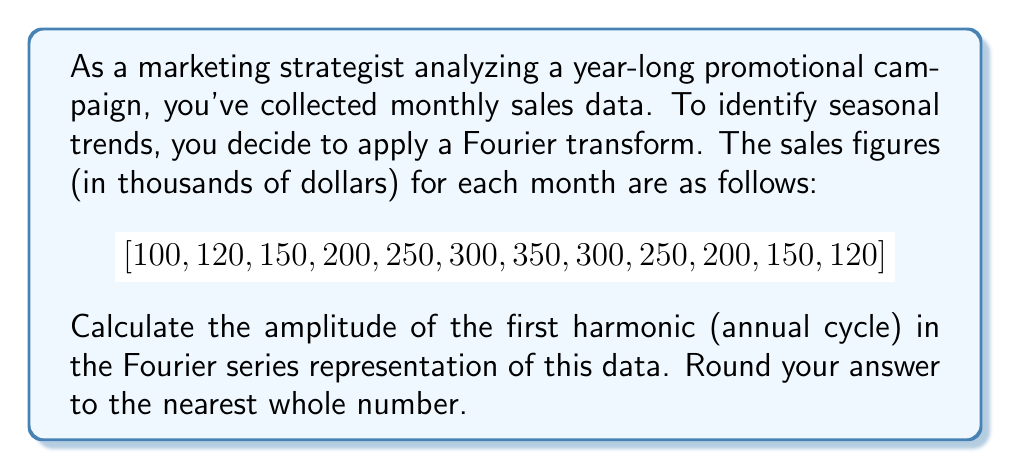Show me your answer to this math problem. To find the amplitude of the first harmonic using the Fourier transform, we'll follow these steps:

1) The first harmonic represents the annual cycle, so we need to calculate the coefficient for $k=1$ in the Fourier series.

2) For a discrete set of N=12 data points, the complex Fourier coefficient $c_k$ is given by:

   $$c_k = \frac{1}{N} \sum_{n=0}^{N-1} x_n e^{-2\pi i k n / N}$$

3) For the first harmonic (k=1), we need to calculate:

   $$c_1 = \frac{1}{12} \sum_{n=0}^{11} x_n e^{-2\pi i n / 12}$$

4) This can be separated into real and imaginary parts:

   $$c_1 = \frac{1}{12} \sum_{n=0}^{11} x_n (\cos(-2\pi n / 12) + i \sin(-2\pi n / 12))$$

5) Calculating this sum:

   Real part: $\frac{1}{12}(100 + 120\cos(-\frac{\pi}{6}) + 150\cos(-\frac{\pi}{3}) + ... + 120\cos(-\frac{11\pi}{6})) \approx -41.67$

   Imaginary part: $\frac{1}{12}(120\sin(-\frac{\pi}{6}) + 150\sin(-\frac{\pi}{3}) + ... + 120\sin(-\frac{11\pi}{6})) \approx -72.17$

6) The amplitude $A_1$ is given by twice the magnitude of this complex coefficient:

   $$A_1 = 2|c_1| = 2\sqrt{(-41.67)^2 + (-72.17)^2} \approx 167.34$$

7) Rounding to the nearest whole number gives 167.
Answer: 167 